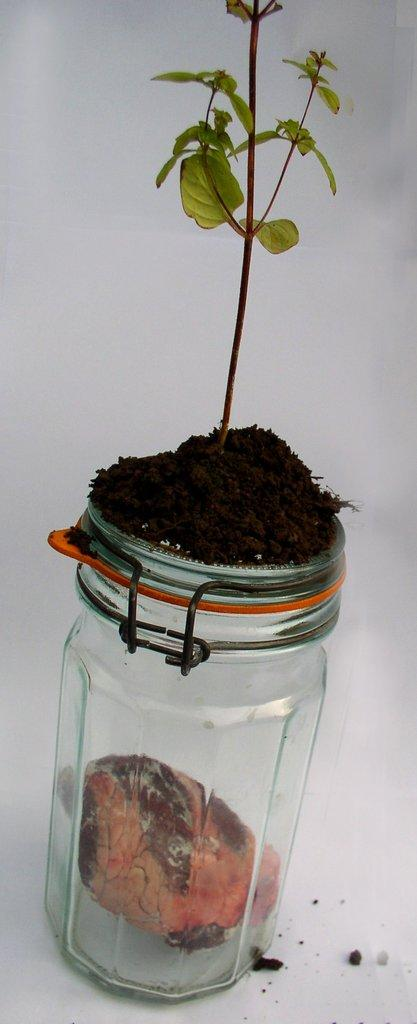What is the main subject of the image? The main subject of the image is a plant. Where is the plant located? The plant is in a pot. Can you describe the position of the pot in the image? The pot is in the center of the image. What type of sidewalk can be seen in the image? There is no sidewalk present in the image; it features a plant in a pot. What does the plant desire in the image? The image does not convey the plant's desires, as it is a still image and not capable of expressing emotions or desires. 